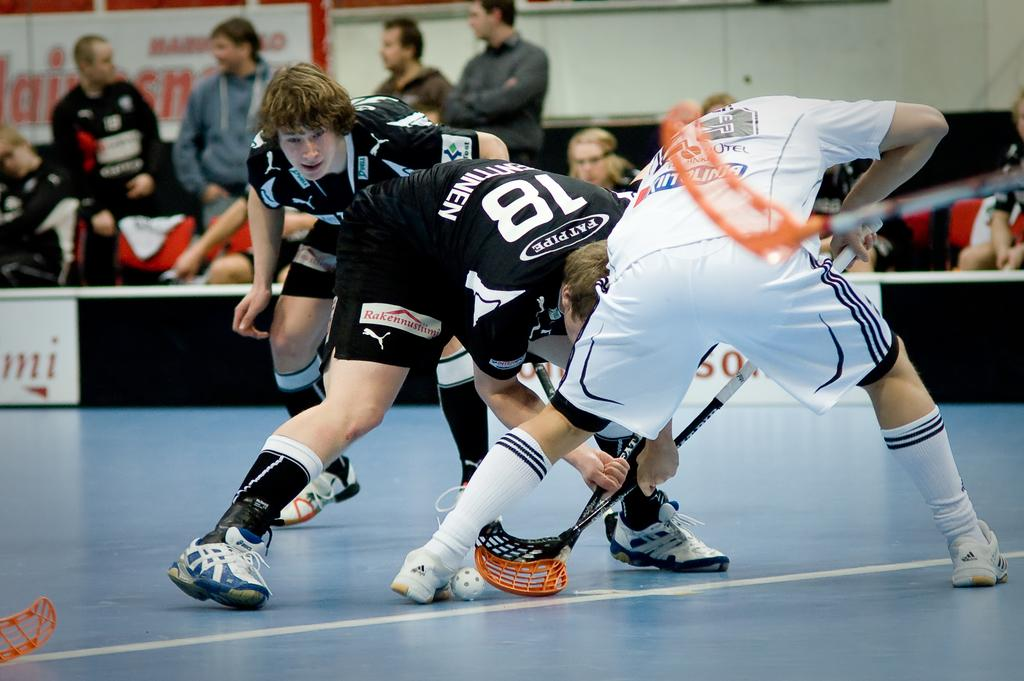<image>
Relay a brief, clear account of the picture shown. Two athletes have their sticks interlocked vying for a ball while one has the number 18 on his back. 